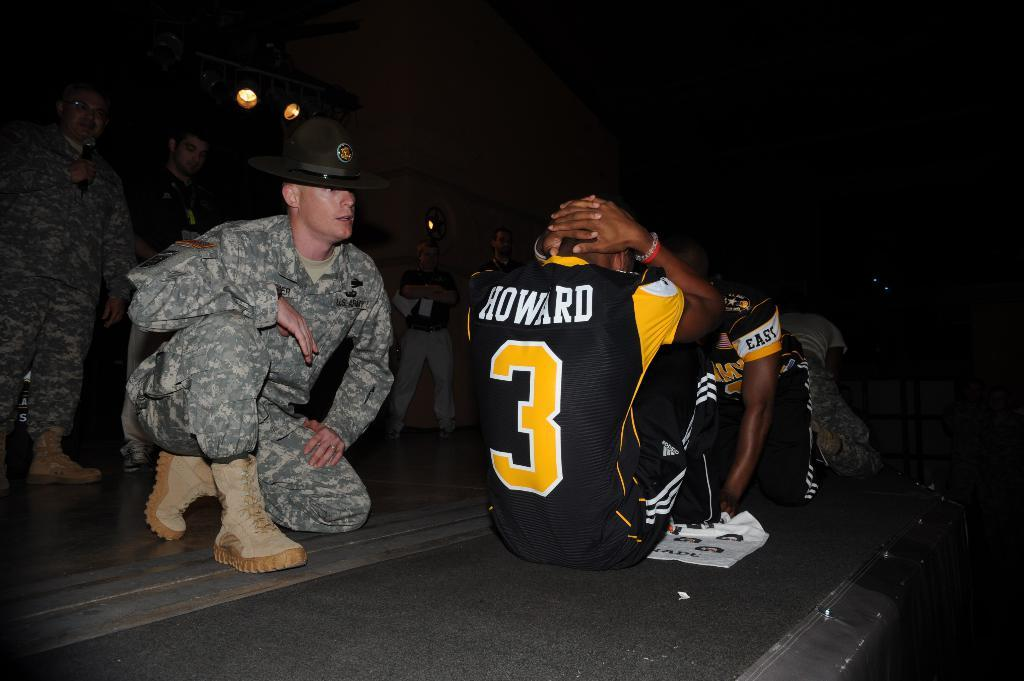<image>
Give a short and clear explanation of the subsequent image. A man in a Howard number 3 jersey is doing sit ups in front of an Army Drill Sergeant. 